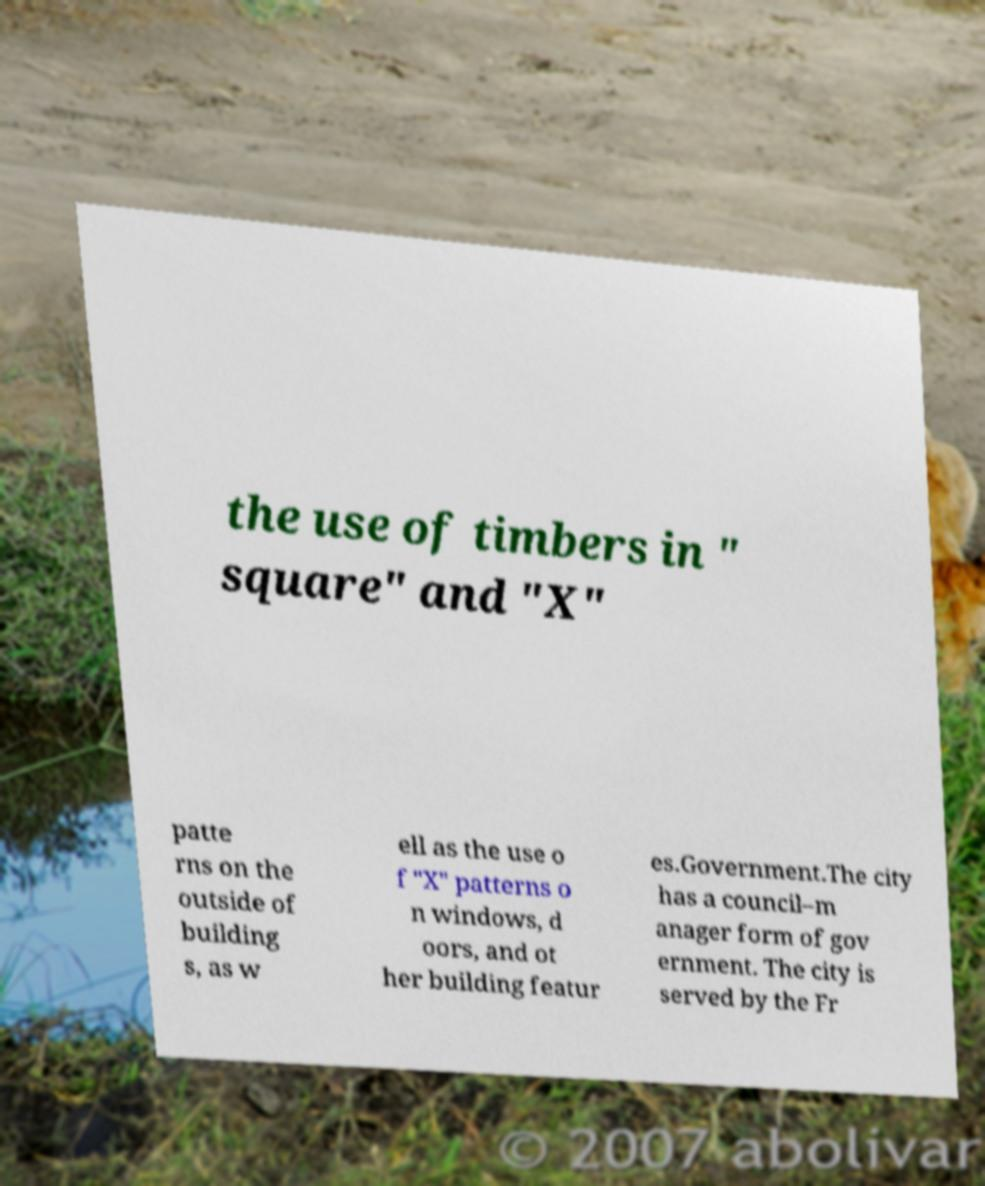Could you extract and type out the text from this image? the use of timbers in " square" and "X" patte rns on the outside of building s, as w ell as the use o f "X" patterns o n windows, d oors, and ot her building featur es.Government.The city has a council–m anager form of gov ernment. The city is served by the Fr 